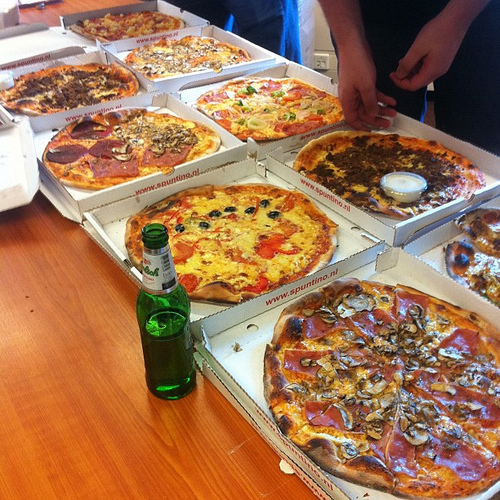Imagine a detective story where the key evidence is hidden in one of these pizza boxes. Which box and what is the evidence? In our detective story, the key evidence is hidden in the second pizza box from the left. Inside this seemingly ordinary box, tucked under the thick layer of melted cheese, lies a small, encrypted USB drive containing critical data that uncovers an international smuggling ring! Upon discovering the USB drive, what is the next step for our detective? Our detective would hurry to the lab to decrypt the USB drive, working closely with a tech expert to uncover the files. With the critical data decrypted, they realize the smuggling ring's next plan involves transporting rare artifacts across borders. The detective must act swiftly, coordinating with international authorities to intercept and apprehend the culprits before the artifacts are lost forever. 